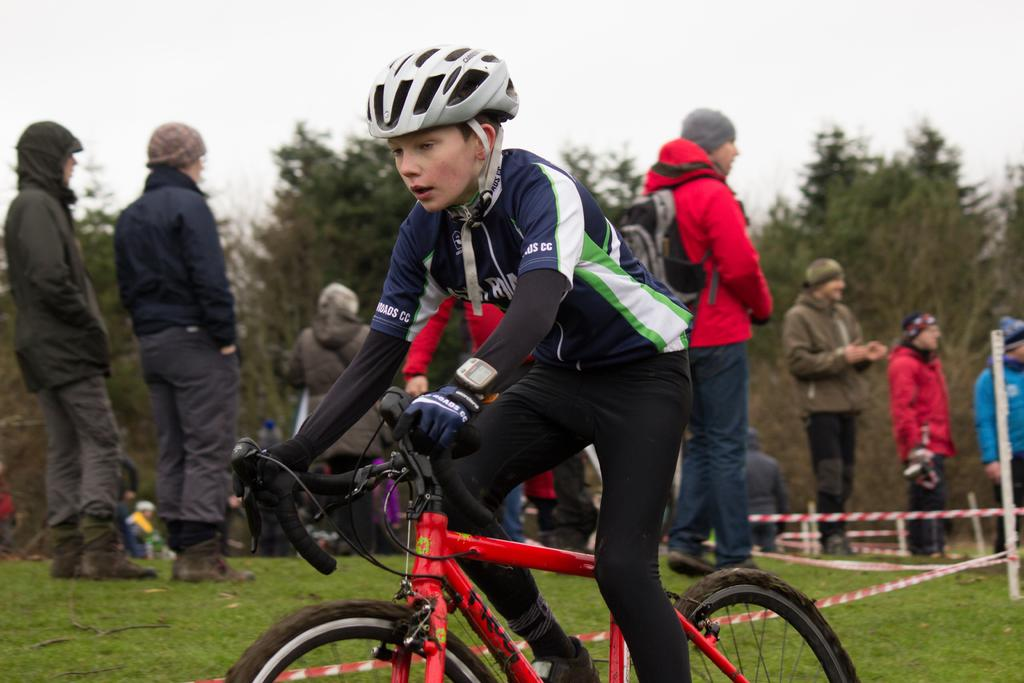What is the main subject of the image? There is a person in the image. What else can be seen in the image besides the person? There is a vehicle in the image. Can you describe the background of the image? In the background of the image, there are persons, poles, trees, grass, and other objects. What is visible at the top of the image? The sky is visible at the top of the image. What unit of measurement is used to determine the person's beginner status in the image? There is no indication of the person's beginner status or any unit of measurement in the image. 